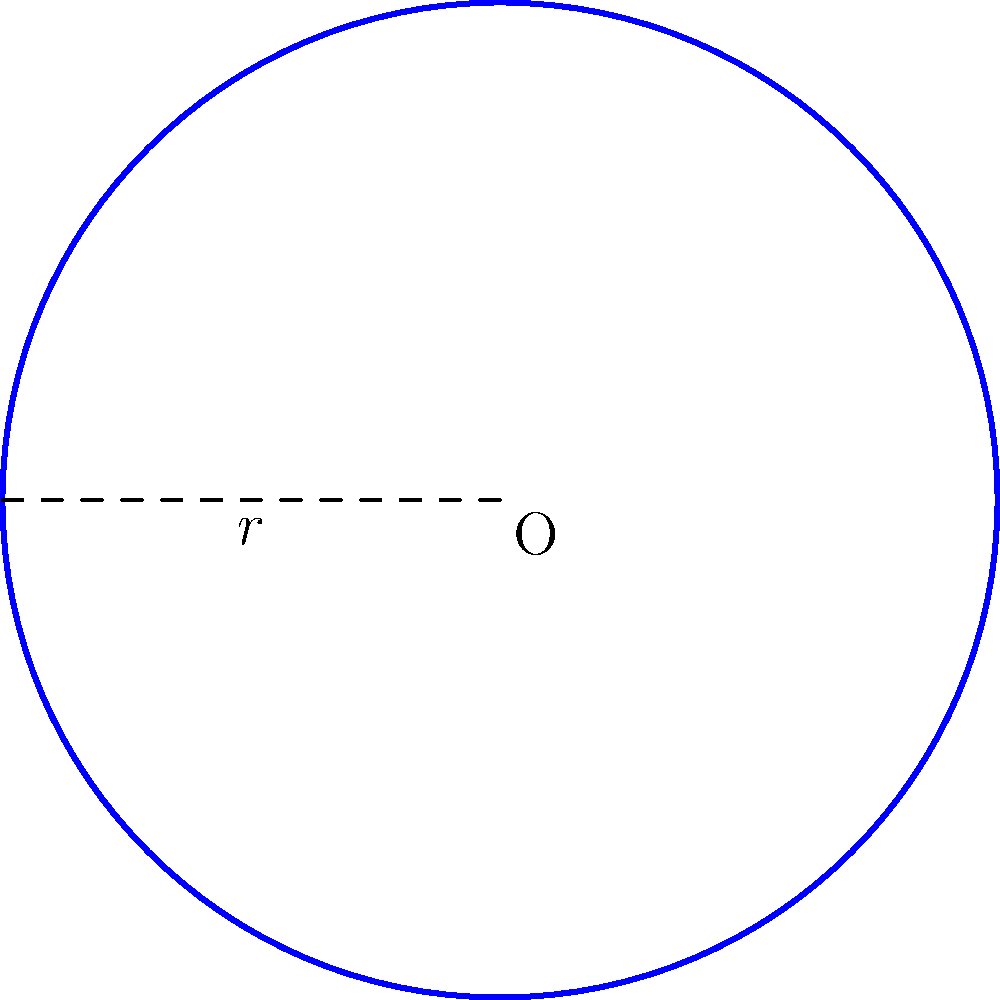At the Atanasio Girardot Sports Complex, a new circular running track is being constructed for aspiring athletes. If the radius of the track is 50 meters, what is the total area of the running surface? To find the area of the circular running track, we need to use the formula for the area of a circle:

$$A = \pi r^2$$

Where:
$A$ = area of the circle
$\pi$ = pi (approximately 3.14159)
$r$ = radius of the circle

Given:
Radius $(r) = 50$ meters

Step 1: Substitute the given radius into the formula.
$$A = \pi (50)^2$$

Step 2: Calculate the square of the radius.
$$A = \pi (2500)$$

Step 3: Multiply by π.
$$A = 7853.98... \text{ m}^2$$

Step 4: Round to the nearest whole number (since we're dealing with a large area).
$$A \approx 7854 \text{ m}^2$$
Answer: 7854 m² 